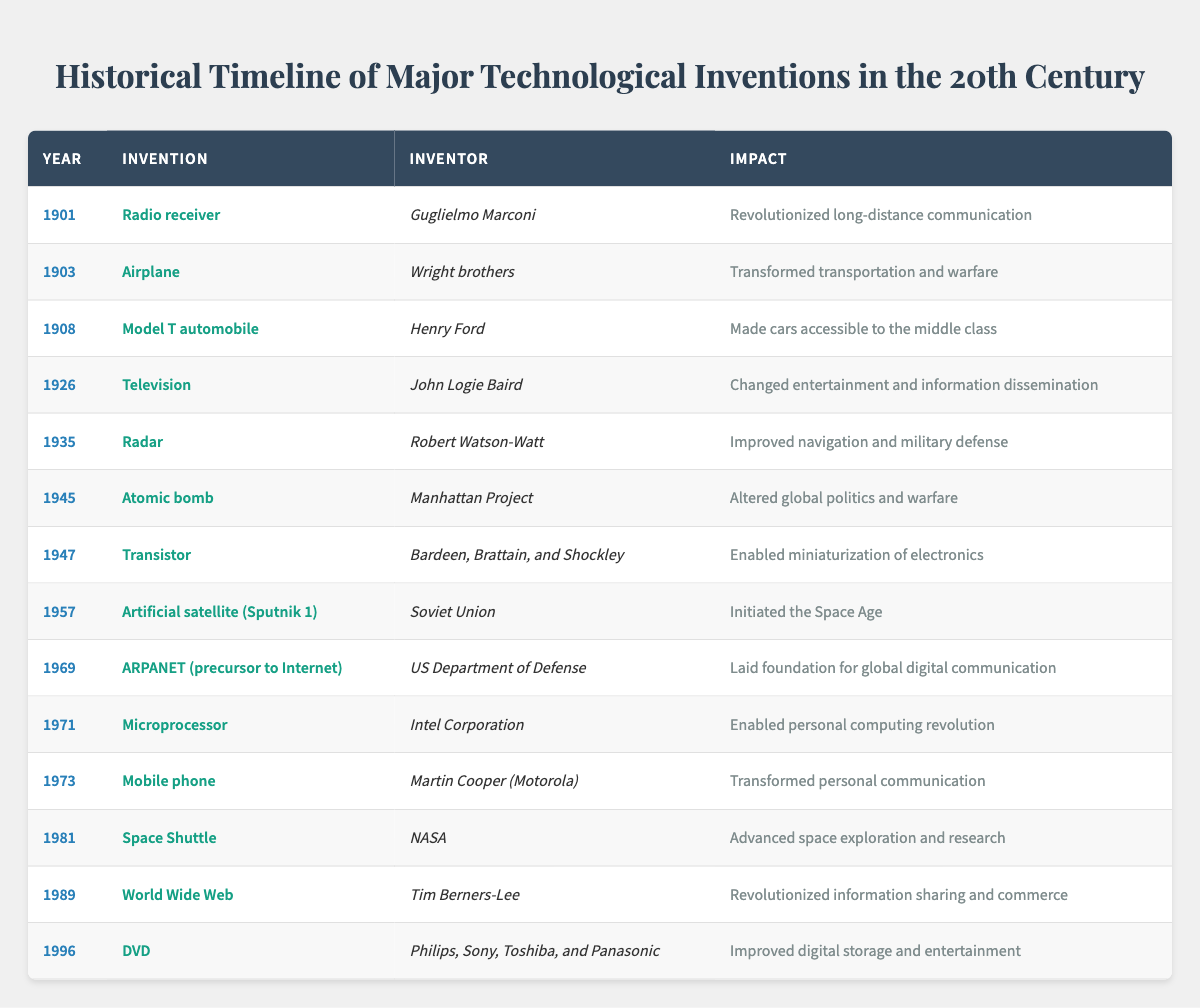What year was the radio receiver invented? The table lists the radio receiver as the invention for the year 1901.
Answer: 1901 Who invented the atomic bomb? According to the table, the atomic bomb was a collective effort known as the Manhattan Project.
Answer: Manhattan Project Which invention was created in 1947? The table shows that the transistor was invented in 1947.
Answer: Transistor How many inventions were introduced before 1950? By counting the years prior to 1950 listed in the table, there are seven inventions: Radio receiver, Airplane, Model T automobile, Television, Radar, Atomic bomb, and Transistor.
Answer: 7 What was the impact of the World Wide Web invention? The table states that the impact of the World Wide Web was the revolutionizing of information sharing and commerce.
Answer: Revolutionized information sharing and commerce Which invention had the greatest impact on personal communication? The mobile phone is listed in the table as having transformed personal communication in 1973.
Answer: Mobile phone Was the radar invented after the television? The radar was invented in 1935 while the television was invented in 1926; therefore, radar was invented after television.
Answer: Yes Which invention has impacted global digital communication? The ARPANET, mentioned in the table as the precursor to the Internet, laid the foundation for global digital communication in 1969.
Answer: ARPANET Count the total number of inventions listed. The table contains a total of 15 inventions.
Answer: 15 Name the second invention listed in chronological order. The second invention after sorting by year is the airplane, invented in 1903.
Answer: Airplane What was the common factor among the inventions from the late 20th century like DVD and World Wide Web? Both the DVD (1996) and World Wide Web (1989) were major technological advancements in digital media and information sharing in the late 20th century.
Answer: Digital media and information sharing 